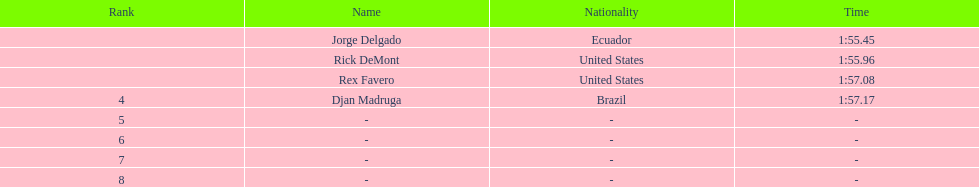What is the time for each name 1:55.45, 1:55.96, 1:57.08, 1:57.17. 